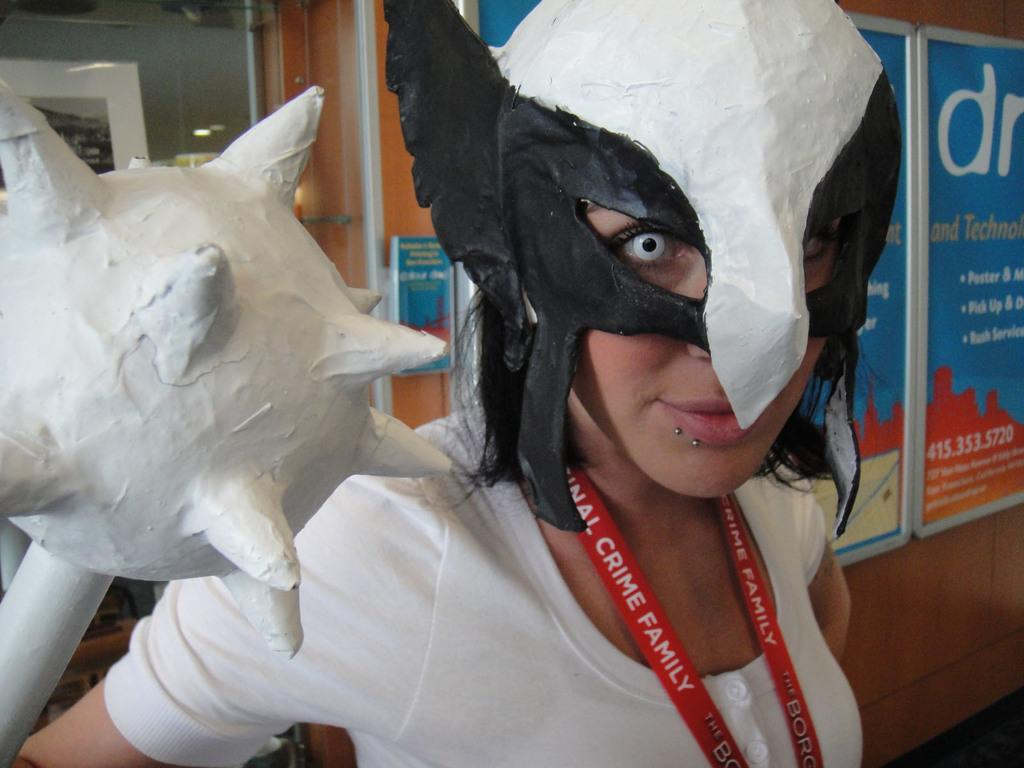Who is present in the image? There is a woman in the image. What is the woman wearing on her face? The woman is wearing a mask. What is the woman holding in her hand? The woman is holding an object with her hand. What can be seen in the background of the image? There are boards, glass, and a wall in the background of the image. Can you see any ducks swimming in the lake in the image? There is no lake or ducks present in the image. What type of leaf is falling from the tree in the image? There is no tree or leaf present in the image. 